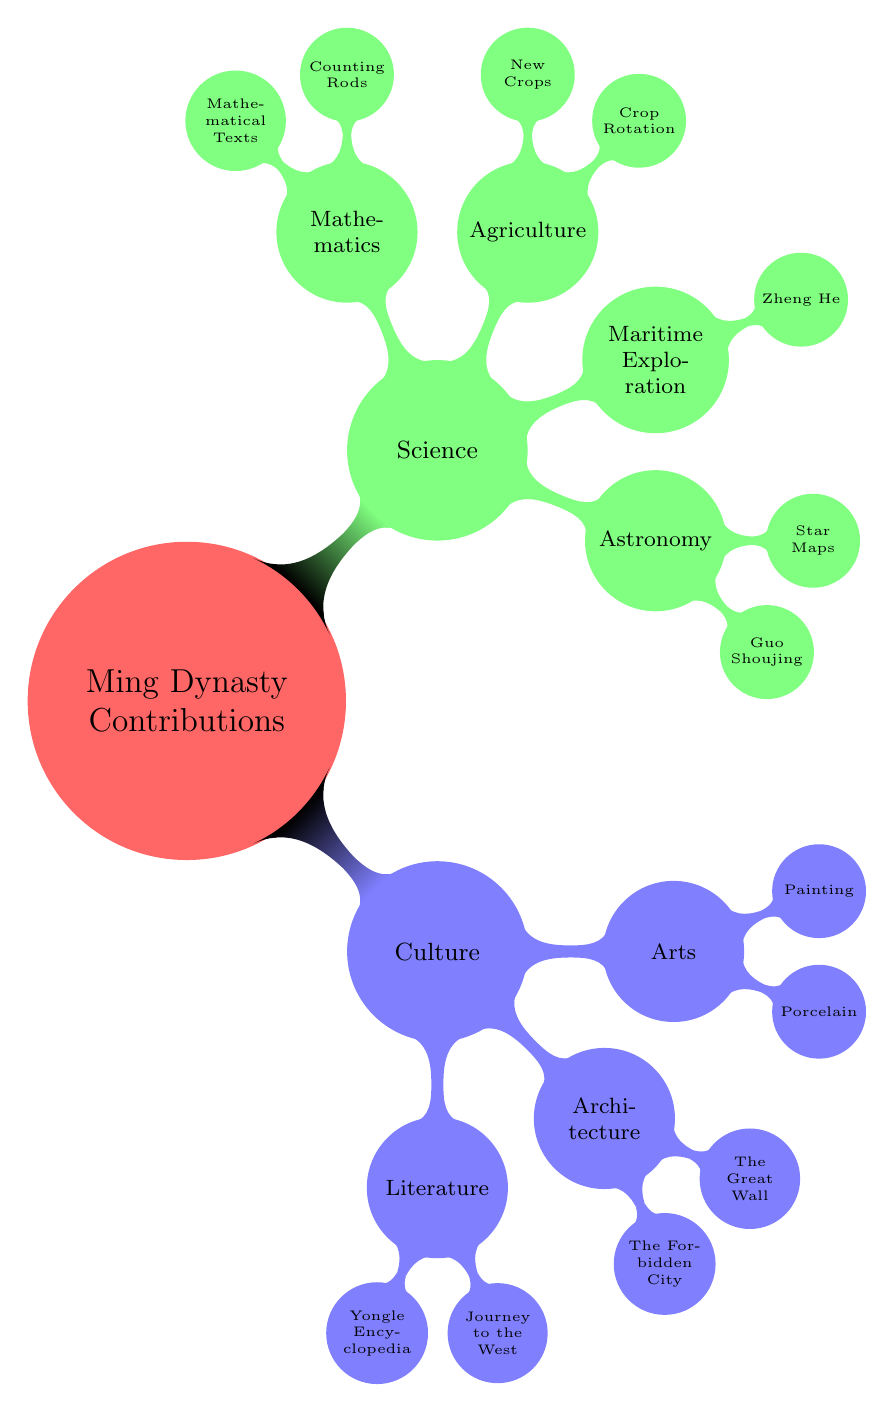What are the two subcategories under Culture? Looking at the first-level nodes under "Ming Dynasty Contributions," the two subcategories listed are "Culture" and "Science." Under "Culture," there are further divisions into "Literature," "Architecture," and "Arts."
Answer: Literature, Architecture, Arts Who is noted for improvements in the calendar system? In the "Science" category, under "Astronomy," the node for "Guo Shoujing" indicates he was an astronomer and engineer noted for this contribution.
Answer: Guo Shoujing How many contributions are listed under Agriculture? Under the "Agriculture" subnode within "Science," there are two listed contributions: "Crop Rotation" and "New Crops." Thus, the total is two.
Answer: 2 Which emperor commissioned the Yongle Encyclopedia? The "Yongle Encyclopedia" is located under the "Literature" subcategory in "Culture" and is directly associated with "Emperor Yongle," who commissioned it.
Answer: Emperor Yongle What type of thematic advancement is represented under "Painting" in the Arts? In the "Arts" subcategory, the node for "Painting" mentions that there was an advancement in techniques and the inclusion of more secular themes, reflecting a thematic shift.
Answer: Secular themes What significant maritime figure is associated with the Ming Dynasty? Within the "Maritime Exploration" subcategory under "Science," the node lists "Zheng He" as a significant figure known for his seven maritime expeditions.
Answer: Zheng He What are the two new crops introduced during Ming agriculture advancements? The "New Crops" node under "Agriculture" mentions the introduction of two specific crops that are "sweet potatoes" and "maize." Thus, these are the two new crops.
Answer: Sweet potatoes, maize What major architectural structure was constructed under Emperor Yongle? The "The Forbidden City" node under "Architecture" specifies that this major structure was constructed during the early Ming Dynasty under Emperor Yongle.
Answer: The Forbidden City Which two types of porcelain are noted for their quality? Under the "Arts" category, the specific type mentioned in relation to high quality is "Ming Blue and White Porcelain."
Answer: Ming Blue and White Porcelain 